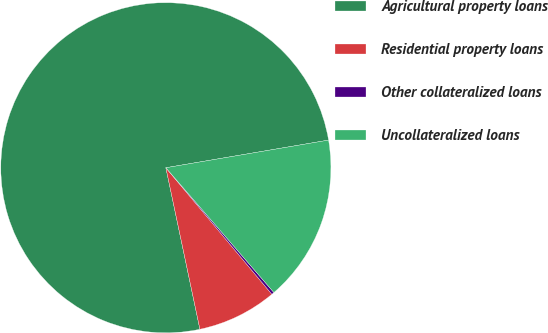<chart> <loc_0><loc_0><loc_500><loc_500><pie_chart><fcel>Agricultural property loans<fcel>Residential property loans<fcel>Other collateralized loans<fcel>Uncollateralized loans<nl><fcel>75.63%<fcel>7.79%<fcel>0.26%<fcel>16.32%<nl></chart> 